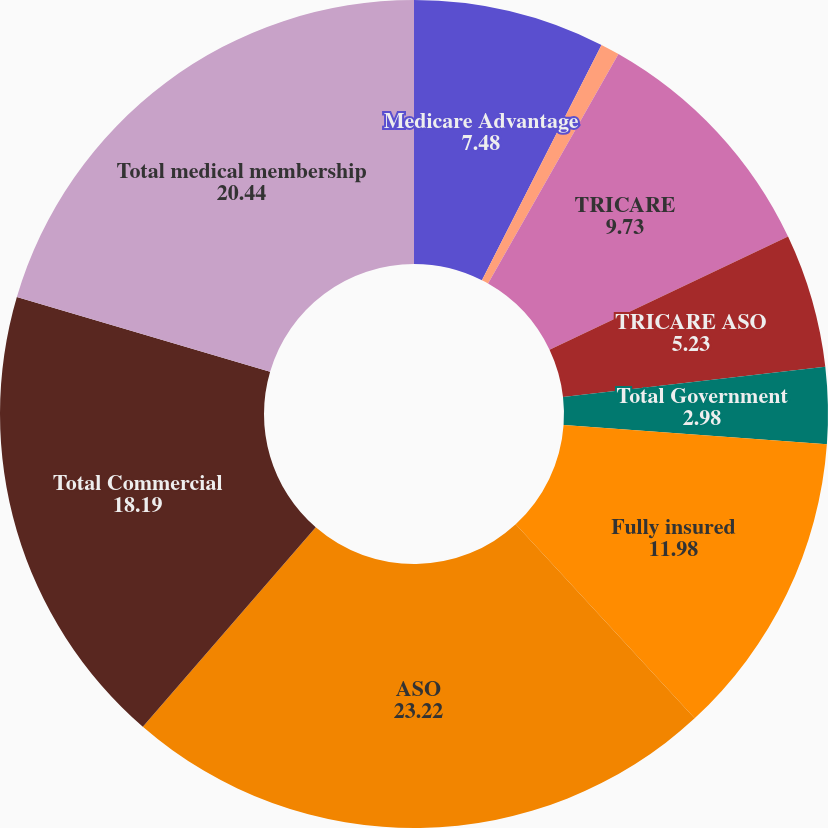Convert chart. <chart><loc_0><loc_0><loc_500><loc_500><pie_chart><fcel>Medicare Advantage<fcel>Medicaid<fcel>TRICARE<fcel>TRICARE ASO<fcel>Total Government<fcel>Fully insured<fcel>ASO<fcel>Total Commercial<fcel>Total medical membership<nl><fcel>7.48%<fcel>0.74%<fcel>9.73%<fcel>5.23%<fcel>2.98%<fcel>11.98%<fcel>23.22%<fcel>18.19%<fcel>20.44%<nl></chart> 